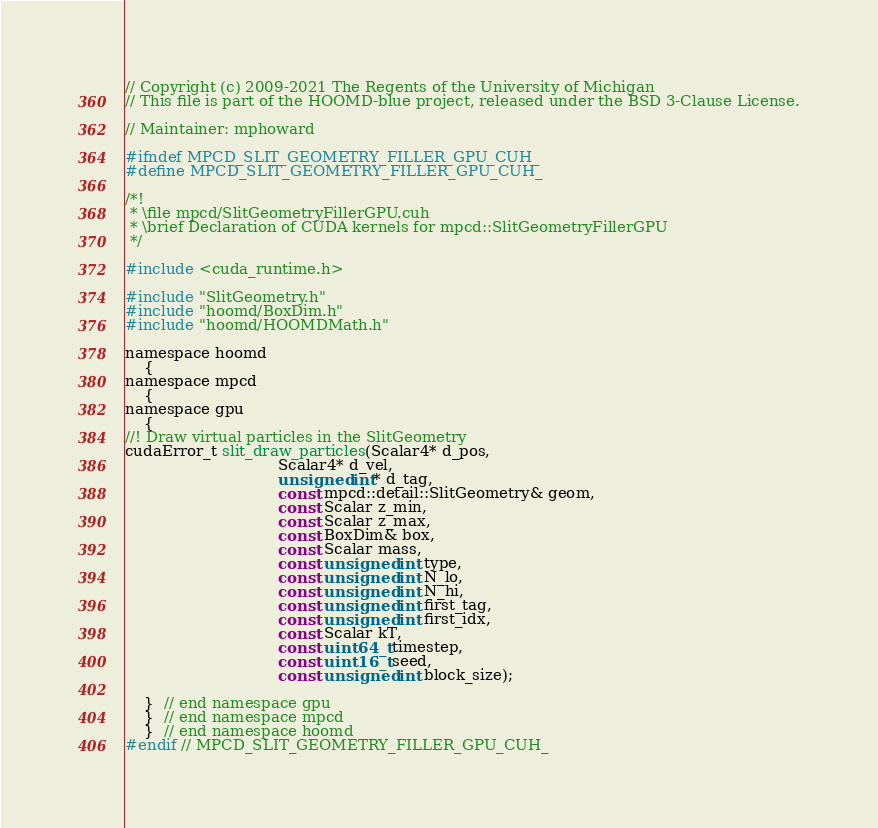Convert code to text. <code><loc_0><loc_0><loc_500><loc_500><_Cuda_>// Copyright (c) 2009-2021 The Regents of the University of Michigan
// This file is part of the HOOMD-blue project, released under the BSD 3-Clause License.

// Maintainer: mphoward

#ifndef MPCD_SLIT_GEOMETRY_FILLER_GPU_CUH_
#define MPCD_SLIT_GEOMETRY_FILLER_GPU_CUH_

/*!
 * \file mpcd/SlitGeometryFillerGPU.cuh
 * \brief Declaration of CUDA kernels for mpcd::SlitGeometryFillerGPU
 */

#include <cuda_runtime.h>

#include "SlitGeometry.h"
#include "hoomd/BoxDim.h"
#include "hoomd/HOOMDMath.h"

namespace hoomd
    {
namespace mpcd
    {
namespace gpu
    {
//! Draw virtual particles in the SlitGeometry
cudaError_t slit_draw_particles(Scalar4* d_pos,
                                Scalar4* d_vel,
                                unsigned int* d_tag,
                                const mpcd::detail::SlitGeometry& geom,
                                const Scalar z_min,
                                const Scalar z_max,
                                const BoxDim& box,
                                const Scalar mass,
                                const unsigned int type,
                                const unsigned int N_lo,
                                const unsigned int N_hi,
                                const unsigned int first_tag,
                                const unsigned int first_idx,
                                const Scalar kT,
                                const uint64_t timestep,
                                const uint16_t seed,
                                const unsigned int block_size);

    }  // end namespace gpu
    }  // end namespace mpcd
    }  // end namespace hoomd
#endif // MPCD_SLIT_GEOMETRY_FILLER_GPU_CUH_
</code> 